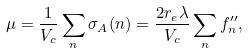<formula> <loc_0><loc_0><loc_500><loc_500>\mu = \frac { 1 } { V _ { c } } \sum _ { n } \sigma _ { A } ( n ) = \frac { 2 r _ { e } \lambda } { V _ { c } } \sum _ { n } f _ { n } ^ { \prime \prime } ,</formula> 